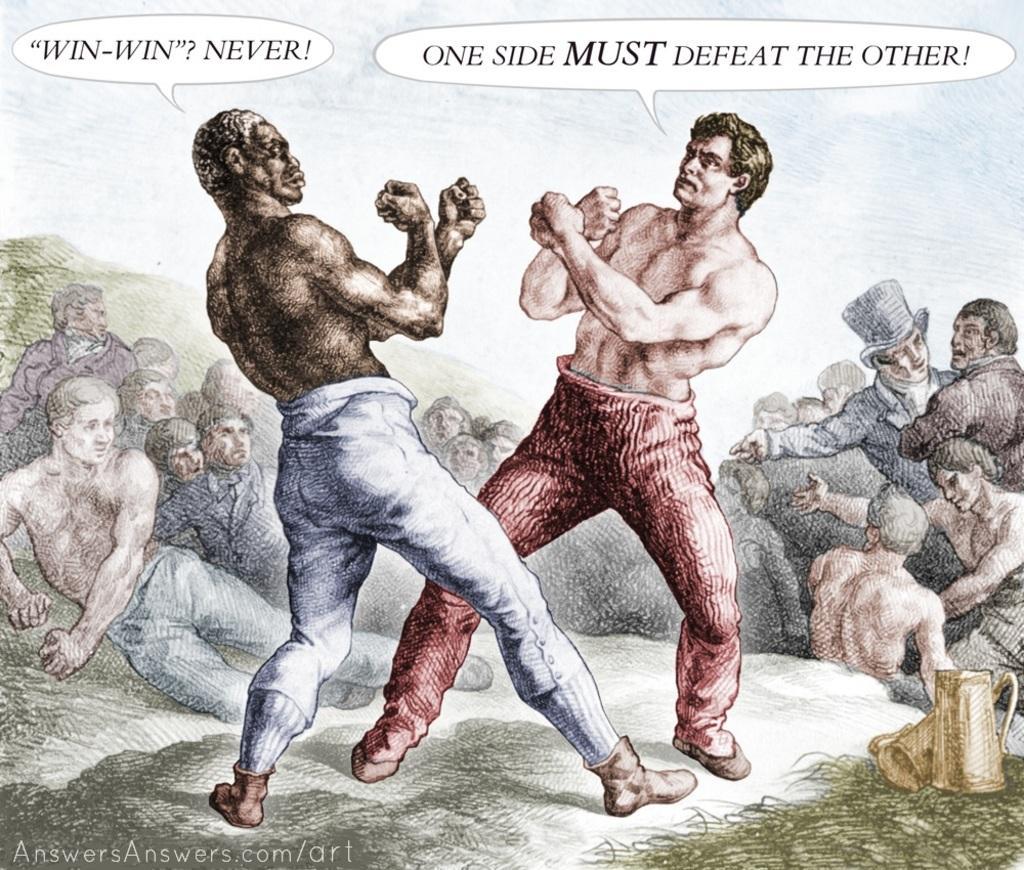Can you describe this image briefly? In this image there is a sketch of two people wrestling, around them there are a few other people watching, at the bottom of the picture there are two jars, on the left of the image there is some text written, on top of the image there is also some text written. 